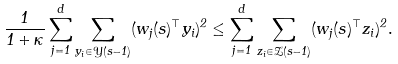Convert formula to latex. <formula><loc_0><loc_0><loc_500><loc_500>\frac { 1 } { 1 + \kappa } \sum _ { j = 1 } ^ { d } \sum _ { y _ { i } \in \mathcal { Y } ( s - 1 ) } ( w _ { j } ( s ) ^ { \top } y _ { i } ) ^ { 2 } \leq \sum _ { j = 1 } ^ { d } \sum _ { z _ { i } \in \mathcal { Z } ( s - 1 ) } ( w _ { j } ( s ) ^ { \top } z _ { i } ) ^ { 2 } .</formula> 